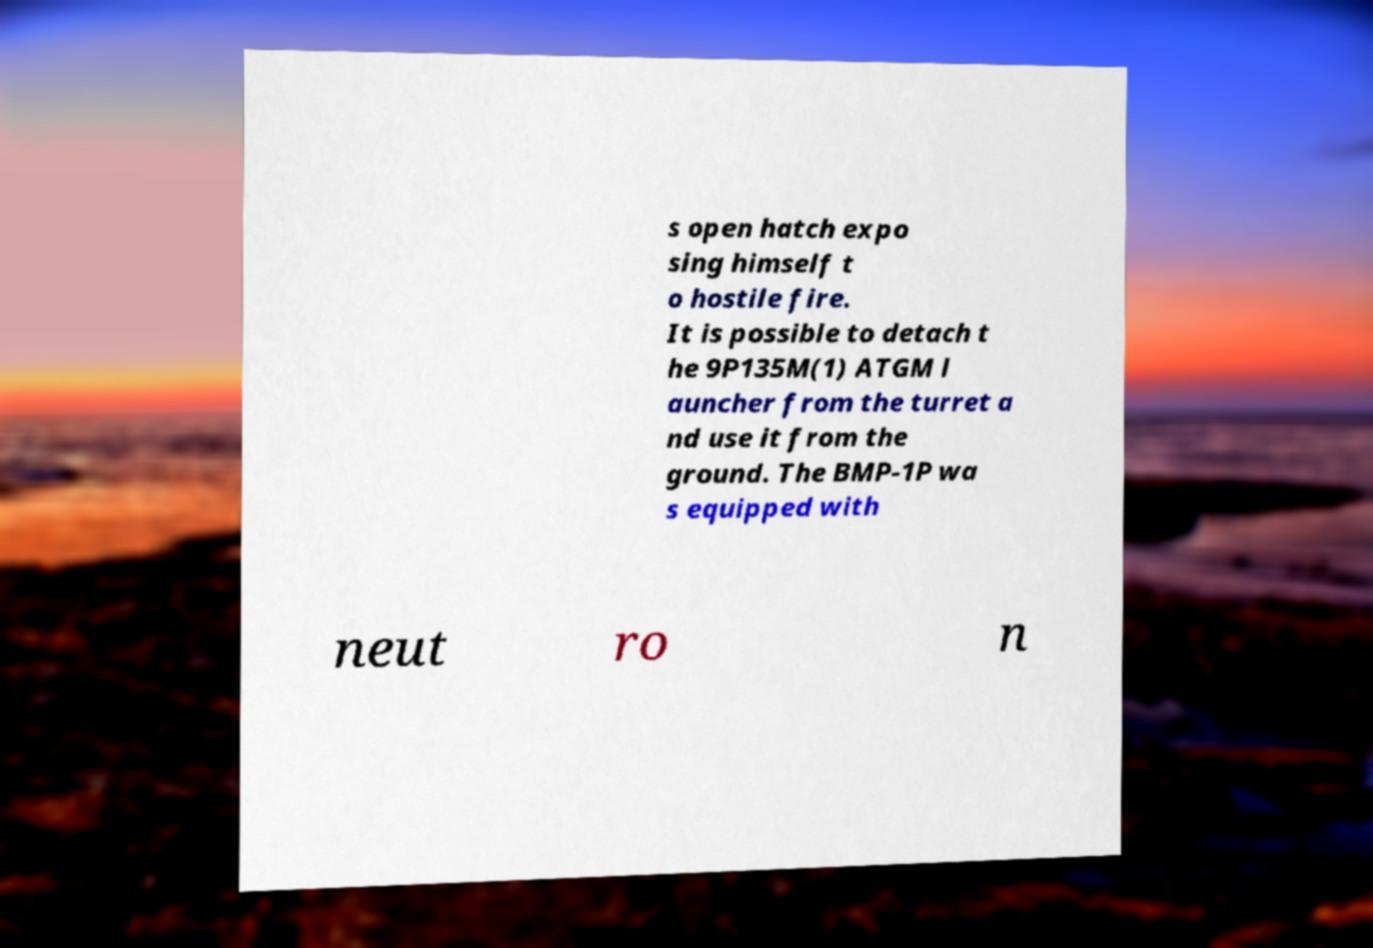Can you accurately transcribe the text from the provided image for me? s open hatch expo sing himself t o hostile fire. It is possible to detach t he 9P135M(1) ATGM l auncher from the turret a nd use it from the ground. The BMP-1P wa s equipped with neut ro n 